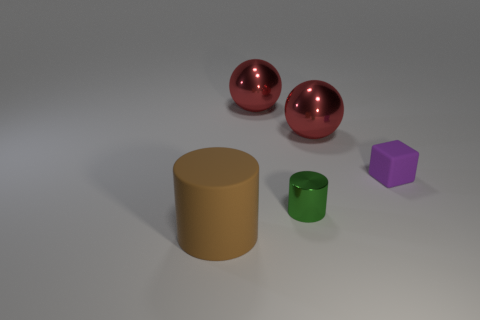What material is the tiny thing to the left of the matte object that is right of the brown cylinder in front of the small shiny cylinder?
Your answer should be very brief. Metal. What number of other large things are the same material as the green thing?
Provide a short and direct response. 2. Is the number of rubber blocks greater than the number of yellow metal objects?
Keep it short and to the point. Yes. There is a small thing in front of the tiny matte thing; how many big objects are in front of it?
Your answer should be compact. 1. How many objects are either small objects that are on the left side of the tiny matte thing or big things?
Make the answer very short. 4. Is there a large rubber object of the same shape as the small shiny object?
Your answer should be compact. Yes. What shape is the large thing that is right of the cylinder on the right side of the matte cylinder?
Keep it short and to the point. Sphere. What number of spheres are either purple things or metal things?
Give a very brief answer. 2. There is a object in front of the small green cylinder; does it have the same shape as the metal thing in front of the tiny block?
Your answer should be very brief. Yes. What color is the object that is left of the small cylinder and behind the small green metallic object?
Offer a very short reply. Red. 